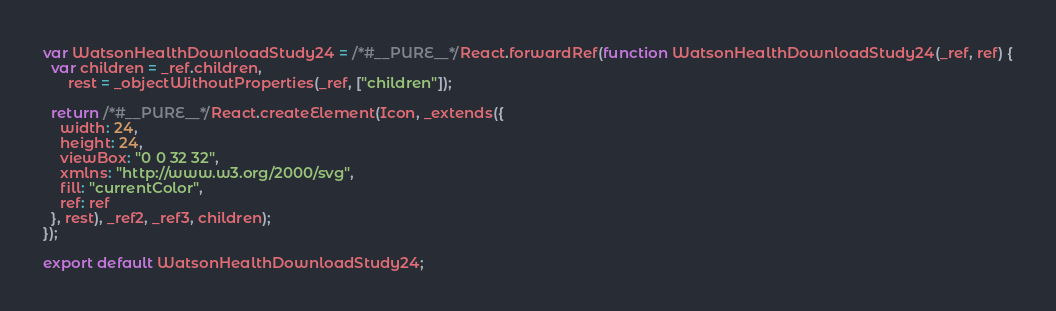<code> <loc_0><loc_0><loc_500><loc_500><_JavaScript_>var WatsonHealthDownloadStudy24 = /*#__PURE__*/React.forwardRef(function WatsonHealthDownloadStudy24(_ref, ref) {
  var children = _ref.children,
      rest = _objectWithoutProperties(_ref, ["children"]);

  return /*#__PURE__*/React.createElement(Icon, _extends({
    width: 24,
    height: 24,
    viewBox: "0 0 32 32",
    xmlns: "http://www.w3.org/2000/svg",
    fill: "currentColor",
    ref: ref
  }, rest), _ref2, _ref3, children);
});

export default WatsonHealthDownloadStudy24;
</code> 